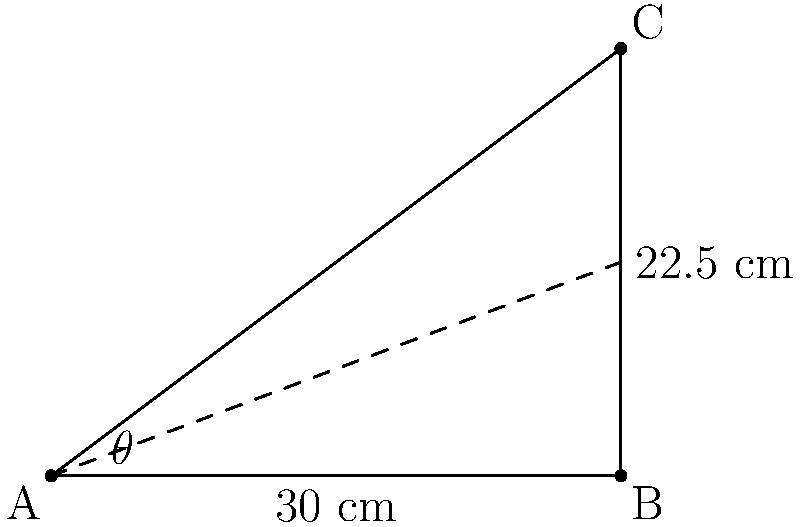A robotic gripper needs to grasp an object securely. The gripper's base is at point A, and it needs to reach an object at point C. The horizontal distance from A to C is 30 cm, and the vertical distance is 22.5 cm. What is the angle of inclination ($\theta$) that the gripper needs to maintain to reach the object efficiently? To find the angle of inclination ($\theta$), we can use the trigonometric function tangent. Here's how we can solve this step-by-step:

1. Identify the right triangle: 
   The triangle ABC is a right triangle with the right angle at B.

2. Identify the opposite and adjacent sides:
   - Opposite side (vertical distance) = 22.5 cm
   - Adjacent side (horizontal distance) = 30 cm

3. Use the tangent function:
   $\tan(\theta) = \frac{\text{opposite}}{\text{adjacent}}$

4. Plug in the values:
   $\tan(\theta) = \frac{22.5}{30}$

5. Simplify:
   $\tan(\theta) = 0.75$

6. To find $\theta$, we need to use the inverse tangent (arctangent) function:
   $\theta = \tan^{-1}(0.75)$

7. Calculate:
   $\theta \approx 36.87°$

Therefore, the angle of inclination that the gripper needs to maintain is approximately 36.87°.
Answer: $36.87°$ 